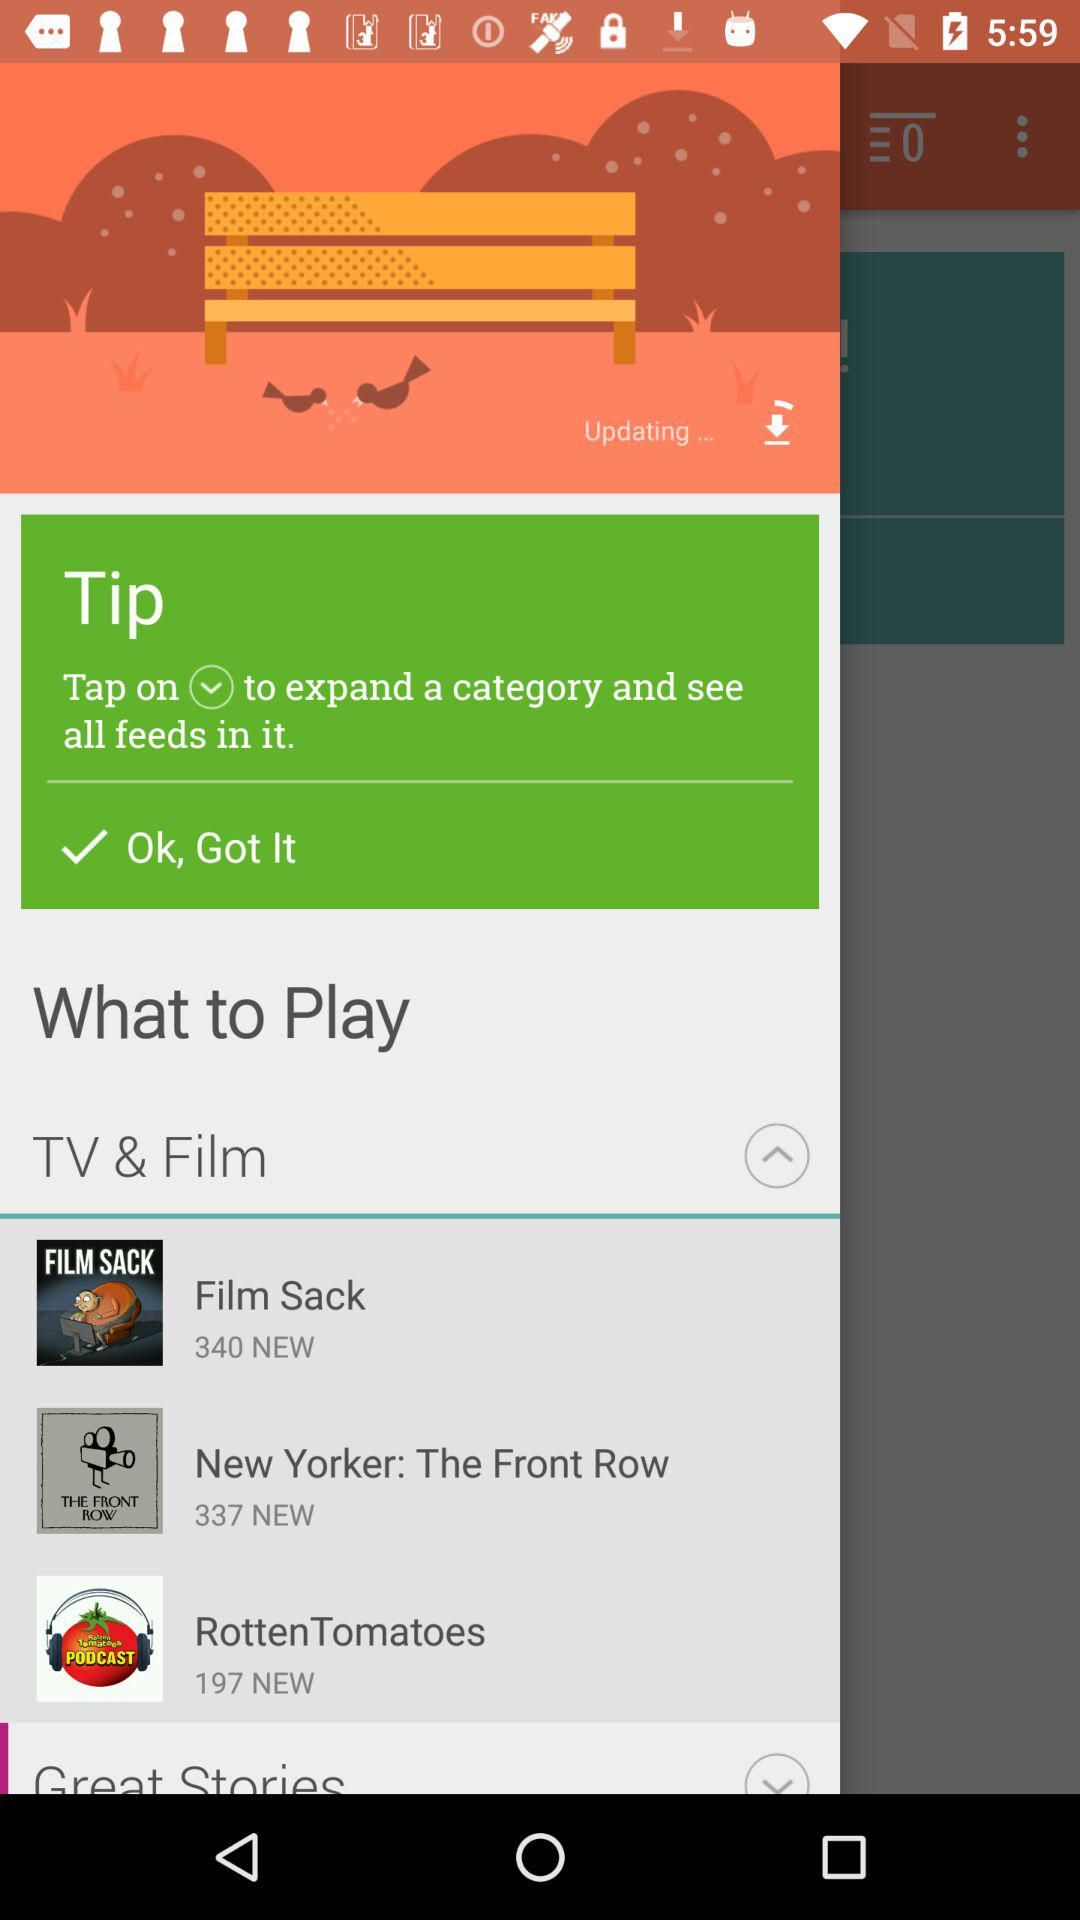What's the count of new episodes in "RottenTomatoes"? The count of new episodes in "RottenTomatoes" is 197. 